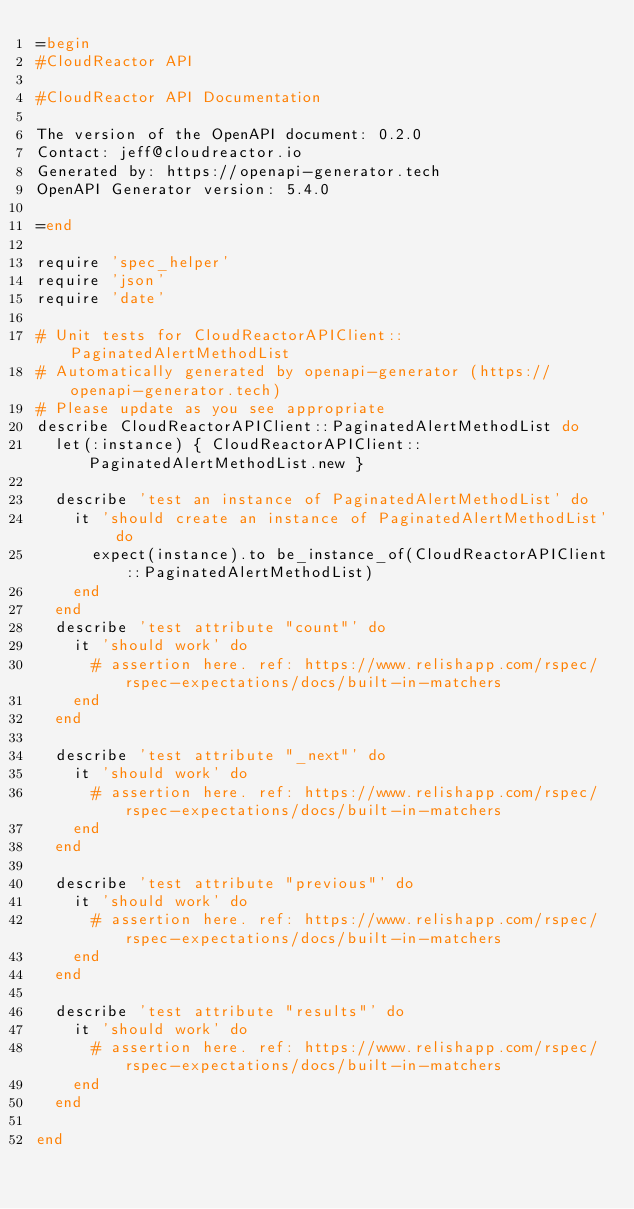Convert code to text. <code><loc_0><loc_0><loc_500><loc_500><_Ruby_>=begin
#CloudReactor API

#CloudReactor API Documentation

The version of the OpenAPI document: 0.2.0
Contact: jeff@cloudreactor.io
Generated by: https://openapi-generator.tech
OpenAPI Generator version: 5.4.0

=end

require 'spec_helper'
require 'json'
require 'date'

# Unit tests for CloudReactorAPIClient::PaginatedAlertMethodList
# Automatically generated by openapi-generator (https://openapi-generator.tech)
# Please update as you see appropriate
describe CloudReactorAPIClient::PaginatedAlertMethodList do
  let(:instance) { CloudReactorAPIClient::PaginatedAlertMethodList.new }

  describe 'test an instance of PaginatedAlertMethodList' do
    it 'should create an instance of PaginatedAlertMethodList' do
      expect(instance).to be_instance_of(CloudReactorAPIClient::PaginatedAlertMethodList)
    end
  end
  describe 'test attribute "count"' do
    it 'should work' do
      # assertion here. ref: https://www.relishapp.com/rspec/rspec-expectations/docs/built-in-matchers
    end
  end

  describe 'test attribute "_next"' do
    it 'should work' do
      # assertion here. ref: https://www.relishapp.com/rspec/rspec-expectations/docs/built-in-matchers
    end
  end

  describe 'test attribute "previous"' do
    it 'should work' do
      # assertion here. ref: https://www.relishapp.com/rspec/rspec-expectations/docs/built-in-matchers
    end
  end

  describe 'test attribute "results"' do
    it 'should work' do
      # assertion here. ref: https://www.relishapp.com/rspec/rspec-expectations/docs/built-in-matchers
    end
  end

end
</code> 